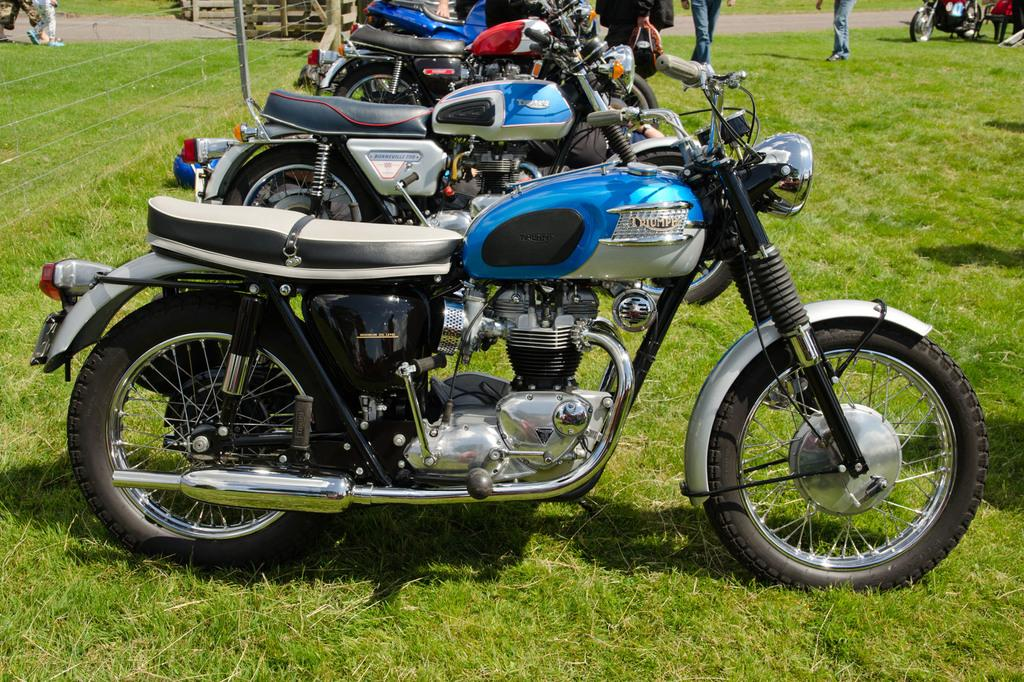What objects are placed in a row in the image? There are bikes placed in a row in the image. What can be seen in the background of the image? There are people in the background of the image. What is located on the left side of the image? There is a fence on the left side of the image. What type of ground is visible at the bottom of the image? There is grass at the bottom of the image. Where is the tray located in the image? There is no tray present in the image. What type of activity is the shake involved in within the image? There is no shake or any activity related to shaking in the image. 